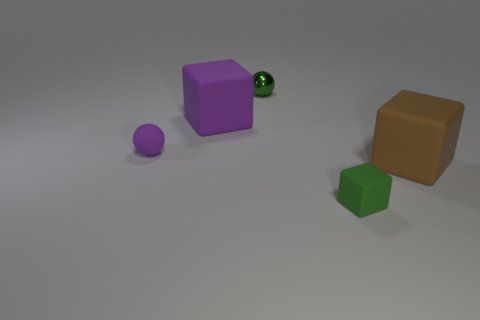Subtract all large purple cubes. How many cubes are left? 2 Add 2 tiny purple spheres. How many objects exist? 7 Subtract all green cubes. How many cubes are left? 2 Subtract 2 blocks. How many blocks are left? 1 Subtract all cyan cylinders. How many gray cubes are left? 0 Subtract 0 yellow cubes. How many objects are left? 5 Subtract all balls. How many objects are left? 3 Subtract all brown cubes. Subtract all purple balls. How many cubes are left? 2 Subtract all purple matte cubes. Subtract all metallic balls. How many objects are left? 3 Add 2 purple blocks. How many purple blocks are left? 3 